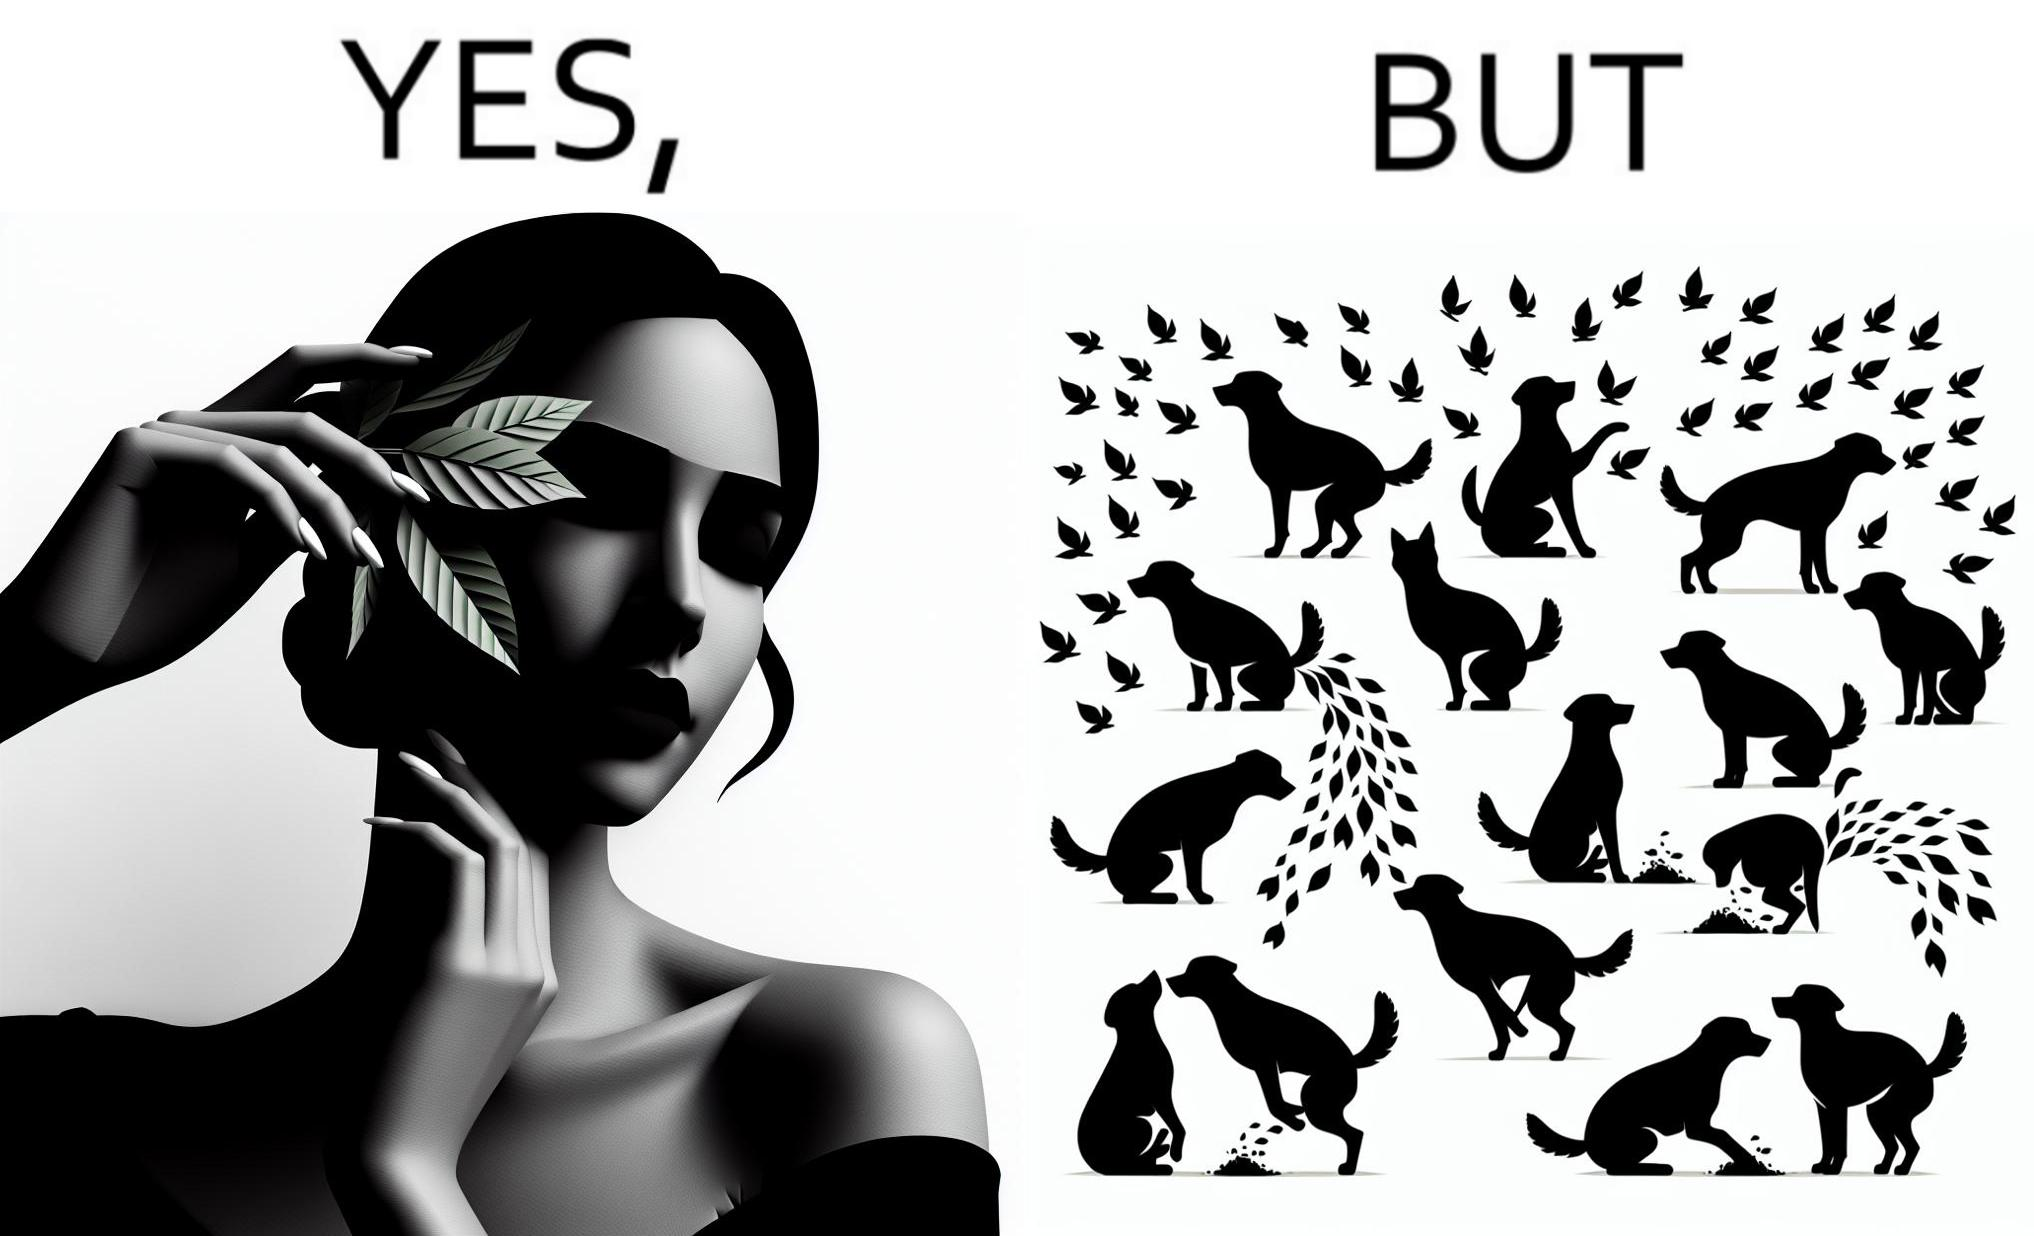Compare the left and right sides of this image. In the left part of the image: It is a woman holding a leaf over half of her face for a good photo In the right part of the image: It is a few dogs defecating and urinating over leaves 